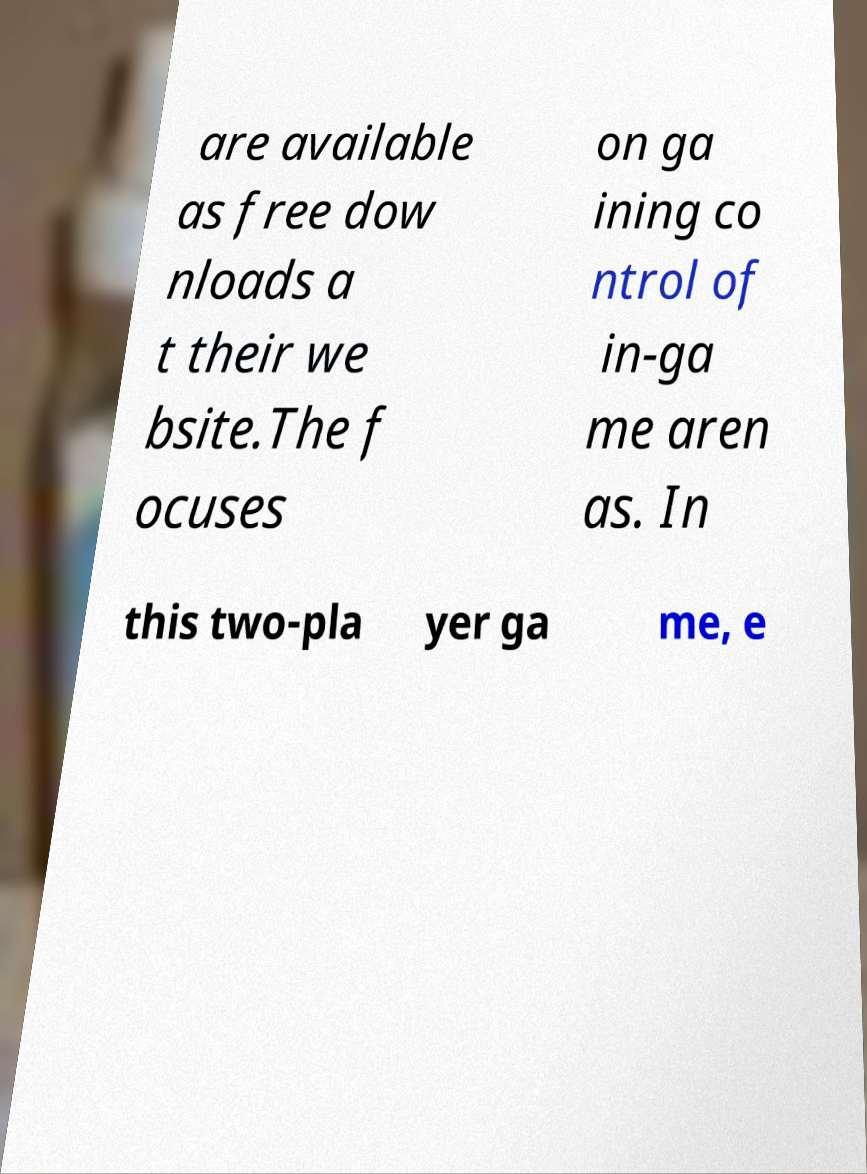What messages or text are displayed in this image? I need them in a readable, typed format. are available as free dow nloads a t their we bsite.The f ocuses on ga ining co ntrol of in-ga me aren as. In this two-pla yer ga me, e 